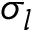Convert formula to latex. <formula><loc_0><loc_0><loc_500><loc_500>\sigma _ { l }</formula> 